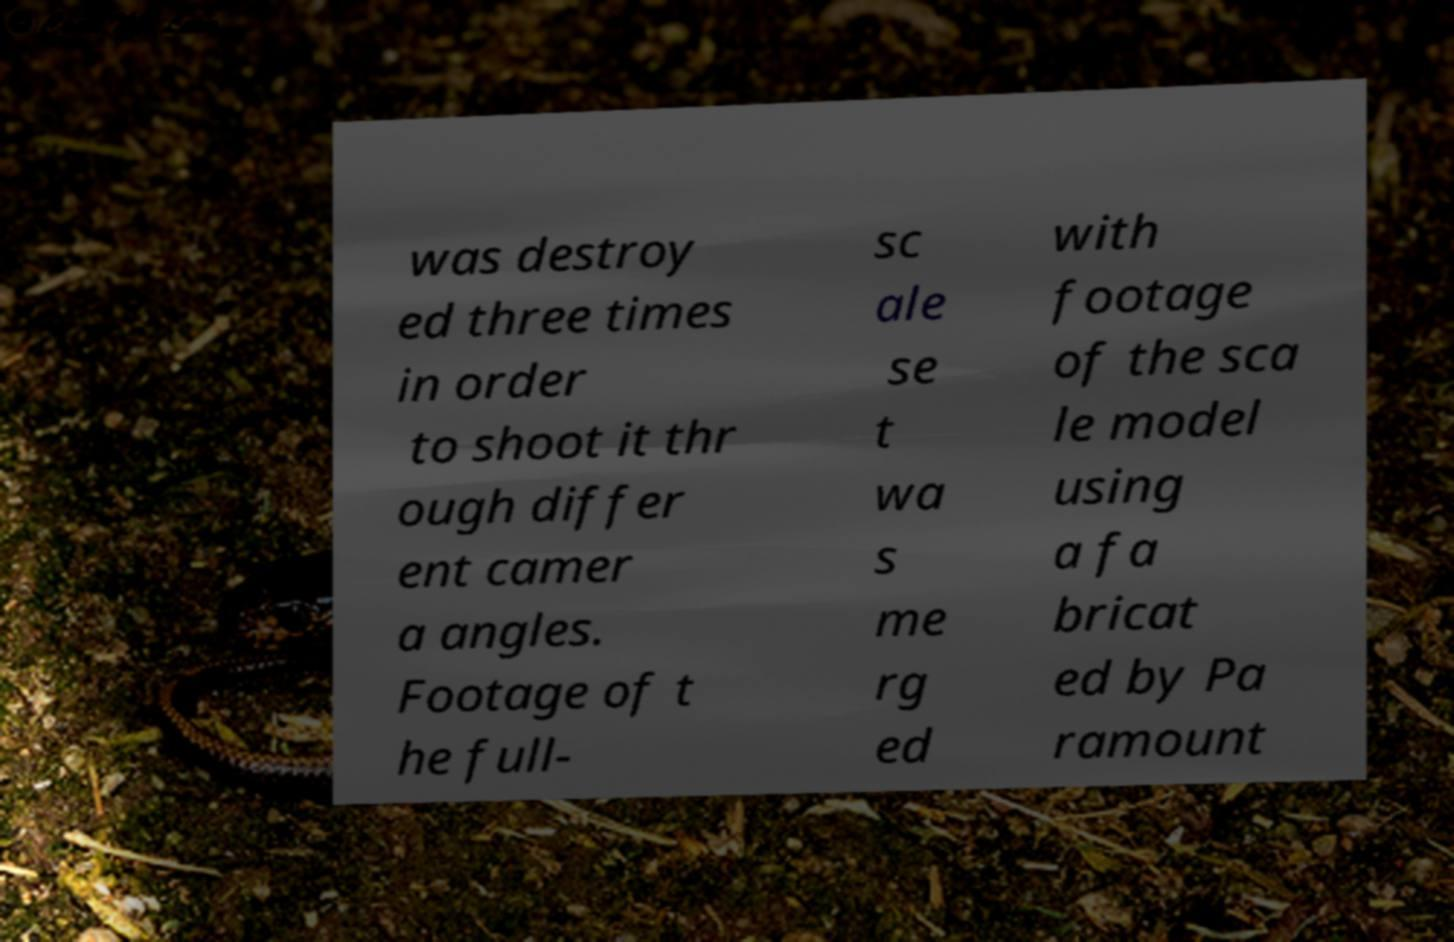What messages or text are displayed in this image? I need them in a readable, typed format. was destroy ed three times in order to shoot it thr ough differ ent camer a angles. Footage of t he full- sc ale se t wa s me rg ed with footage of the sca le model using a fa bricat ed by Pa ramount 